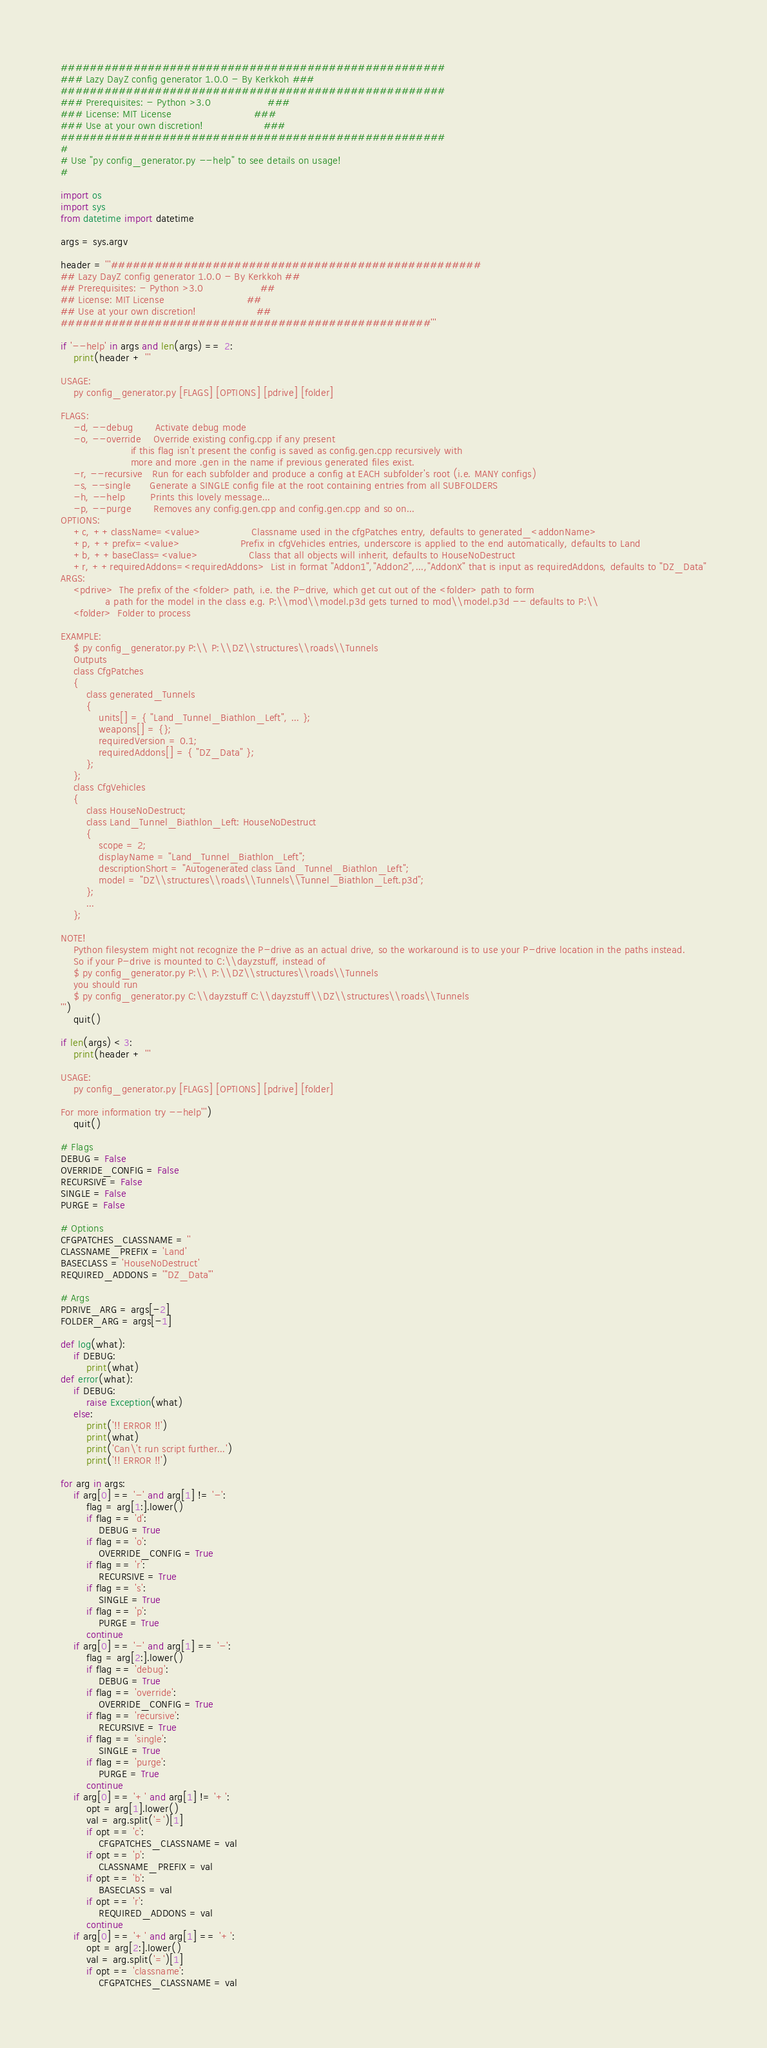<code> <loc_0><loc_0><loc_500><loc_500><_Python_>#####################################################
### Lazy DayZ config generator 1.0.0 - By Kerkkoh ###
#####################################################
### Prerequisites: - Python >3.0                  ###
### License: MIT License                          ###
### Use at your own discretion!                   ###
#####################################################
#
# Use "py config_generator.py --help" to see details on usage!
#

import os
import sys
from datetime import datetime

args = sys.argv

header = '''###################################################
## Lazy DayZ config generator 1.0.0 - By Kerkkoh ##
## Prerequisites: - Python >3.0                  ##
## License: MIT License                          ##
## Use at your own discretion!                   ##
###################################################'''

if '--help' in args and len(args) == 2:
    print(header + '''

USAGE:
    py config_generator.py [FLAGS] [OPTIONS] [pdrive] [folder]

FLAGS:
    -d, --debug       Activate debug mode
    -o, --override    Override existing config.cpp if any present
                      if this flag isn't present the config is saved as config.gen.cpp recursively with
                      more and more .gen in the name if previous generated files exist.
    -r, --recursive   Run for each subfolder and produce a config at EACH subfolder's root (i.e. MANY configs)
    -s, --single      Generate a SINGLE config file at the root containing entries from all SUBFOLDERS
    -h, --help        Prints this lovely message...
    -p, --purge       Removes any config.gen.cpp and config.gen.cpp and so on...
OPTIONS:
    +c, ++className=<value>                Classname used in the cfgPatches entry, defaults to generated_<addonName>
    +p, ++prefix=<value>                   Prefix in cfgVehicles entries, underscore is applied to the end automatically, defaults to Land
    +b, ++baseClass=<value>                Class that all objects will inherit, defaults to HouseNoDestruct
    +r, ++requiredAddons=<requiredAddons>  List in format "Addon1","Addon2",...,"AddonX" that is input as requiredAddons, defaults to "DZ_Data"
ARGS:
    <pdrive>  The prefix of the <folder> path, i.e. the P-drive, which get cut out of the <folder> path to form
              a path for the model in the class e.g. P:\\mod\\model.p3d gets turned to mod\\model.p3d -- defaults to P:\\
    <folder>  Folder to process

EXAMPLE:
    $ py config_generator.py P:\\ P:\\DZ\\structures\\roads\\Tunnels
    Outputs
    class CfgPatches
    {
        class generated_Tunnels
        {
            units[] = { "Land_Tunnel_Biathlon_Left", ... };
            weapons[] = {};
            requiredVersion = 0.1;
            requiredAddons[] = { "DZ_Data" };
        };
    };
    class CfgVehicles
    {
        class HouseNoDestruct;
        class Land_Tunnel_Biathlon_Left: HouseNoDestruct
        {
            scope = 2;
            displayName = "Land_Tunnel_Biathlon_Left";
            descriptionShort = "Autogenerated class Land_Tunnel_Biathlon_Left";
            model = "DZ\\structures\\roads\\Tunnels\\Tunnel_Biathlon_Left.p3d";
        };
        ...
    };

NOTE!
    Python filesystem might not recognize the P-drive as an actual drive, so the workaround is to use your P-drive location in the paths instead.
    So if your P-drive is mounted to C:\\dayzstuff, instead of
    $ py config_generator.py P:\\ P:\\DZ\\structures\\roads\\Tunnels
    you should run
    $ py config_generator.py C:\\dayzstuff C:\\dayzstuff\\DZ\\structures\\roads\\Tunnels
''')
    quit()

if len(args) < 3:
    print(header + '''

USAGE:
    py config_generator.py [FLAGS] [OPTIONS] [pdrive] [folder]

For more information try --help''')
    quit()

# Flags
DEBUG = False
OVERRIDE_CONFIG = False
RECURSIVE = False
SINGLE = False
PURGE = False

# Options
CFGPATCHES_CLASSNAME = ''
CLASSNAME_PREFIX = 'Land'
BASECLASS = 'HouseNoDestruct'
REQUIRED_ADDONS = '"DZ_Data"'

# Args
PDRIVE_ARG = args[-2]
FOLDER_ARG = args[-1]

def log(what):
    if DEBUG:
        print(what)
def error(what):
    if DEBUG:
        raise Exception(what)
    else:
        print('!! ERROR !!')
        print(what)
        print('Can\'t run script further...')
        print('!! ERROR !!')

for arg in args:
    if arg[0] == '-' and arg[1] != '-':
        flag = arg[1:].lower()
        if flag == 'd':
            DEBUG = True
        if flag == 'o':
            OVERRIDE_CONFIG = True
        if flag == 'r':
            RECURSIVE = True
        if flag == 's':
            SINGLE = True
        if flag == 'p':
            PURGE = True
        continue
    if arg[0] == '-' and arg[1] == '-':
        flag = arg[2:].lower()
        if flag == 'debug':
            DEBUG = True
        if flag == 'override':
            OVERRIDE_CONFIG = True
        if flag == 'recursive':
            RECURSIVE = True
        if flag == 'single':
            SINGLE = True
        if flag == 'purge':
            PURGE = True
        continue
    if arg[0] == '+' and arg[1] != '+':
        opt = arg[1].lower()
        val = arg.split('=')[1]
        if opt == 'c':
            CFGPATCHES_CLASSNAME = val
        if opt == 'p':
            CLASSNAME_PREFIX = val
        if opt == 'b':
            BASECLASS = val
        if opt == 'r':
            REQUIRED_ADDONS = val
        continue
    if arg[0] == '+' and arg[1] == '+':
        opt = arg[2:].lower()
        val = arg.split('=')[1]
        if opt == 'classname':
            CFGPATCHES_CLASSNAME = val</code> 